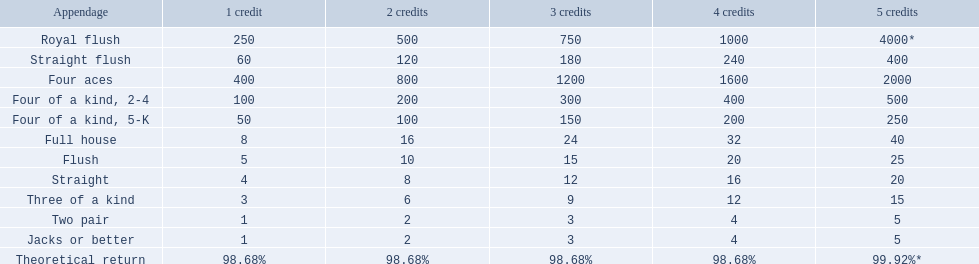What are the top 5 best types of hand for winning? Royal flush, Straight flush, Four aces, Four of a kind, 2-4, Four of a kind, 5-K. Between those 5, which of those hands are four of a kind? Four of a kind, 2-4, Four of a kind, 5-K. Of those 2 hands, which is the best kind of four of a kind for winning? Four of a kind, 2-4. 